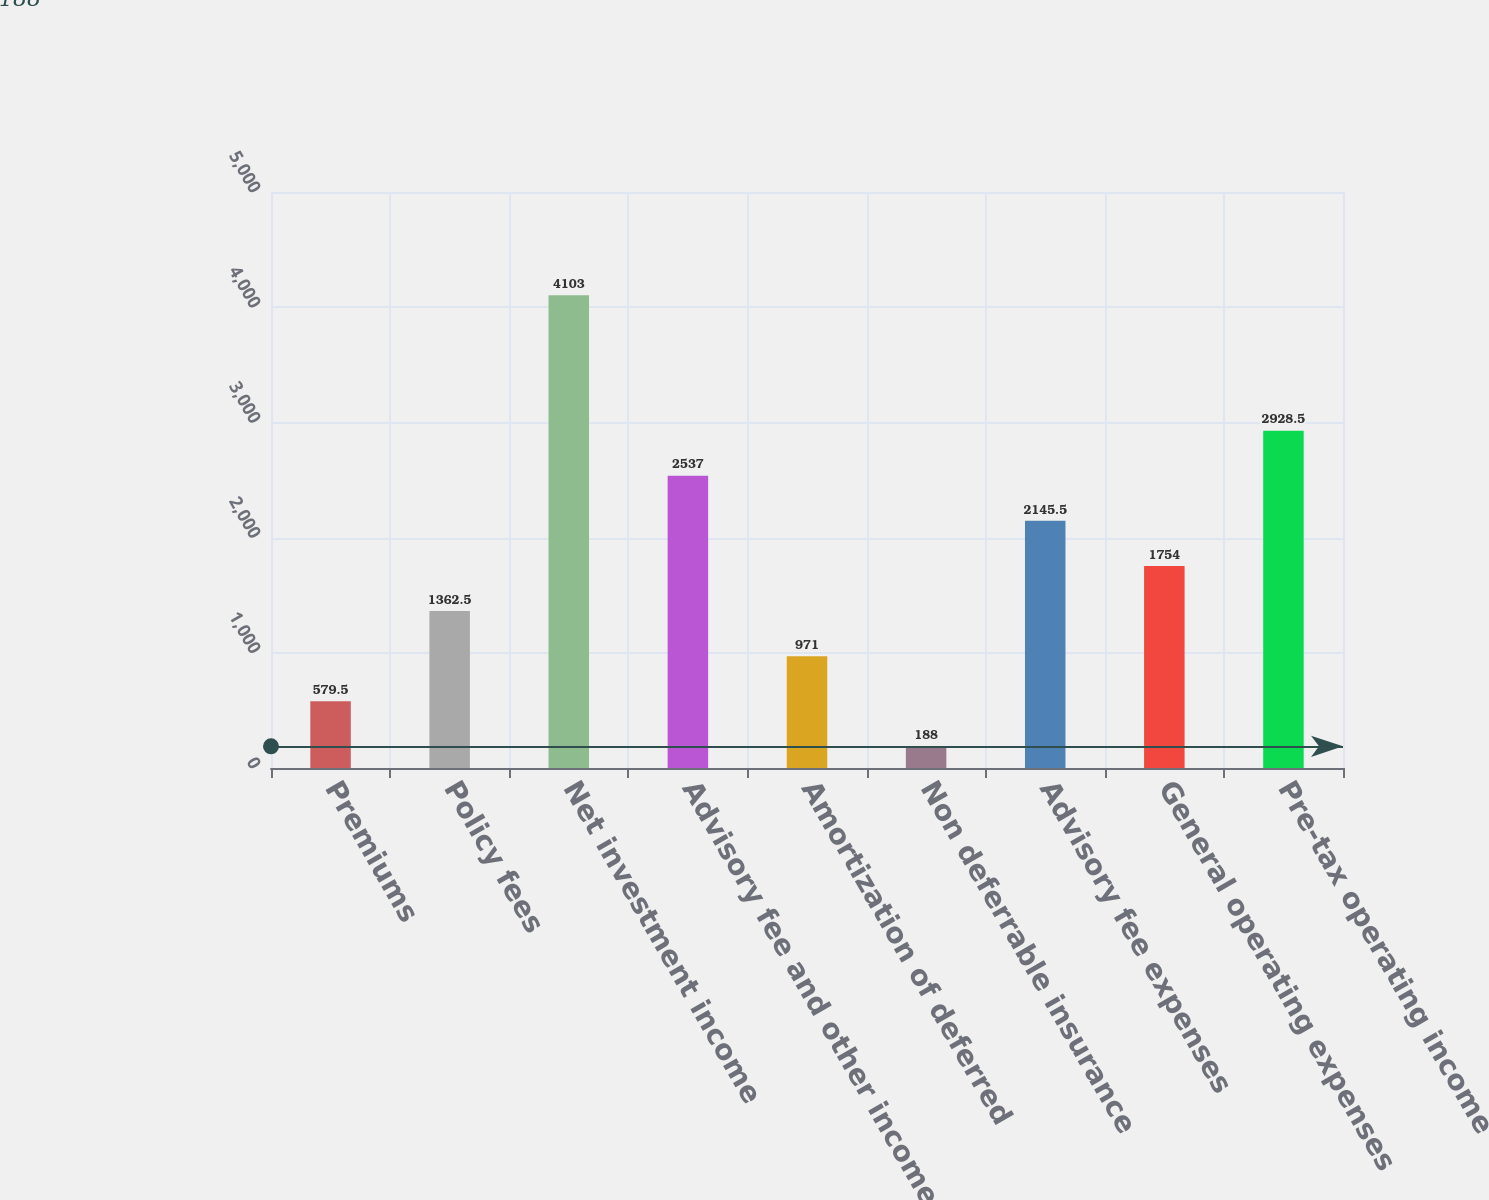Convert chart. <chart><loc_0><loc_0><loc_500><loc_500><bar_chart><fcel>Premiums<fcel>Policy fees<fcel>Net investment income<fcel>Advisory fee and other income<fcel>Amortization of deferred<fcel>Non deferrable insurance<fcel>Advisory fee expenses<fcel>General operating expenses<fcel>Pre-tax operating income<nl><fcel>579.5<fcel>1362.5<fcel>4103<fcel>2537<fcel>971<fcel>188<fcel>2145.5<fcel>1754<fcel>2928.5<nl></chart> 